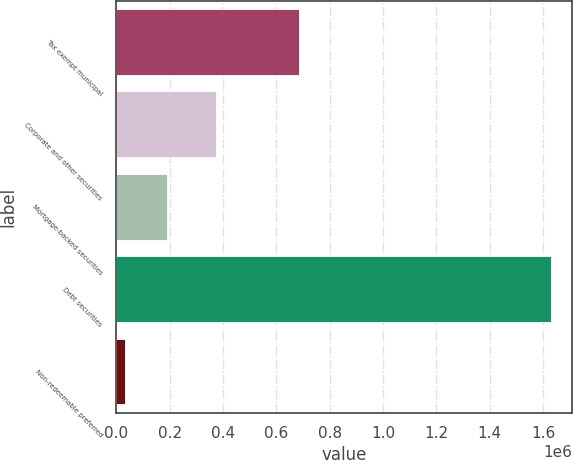Convert chart. <chart><loc_0><loc_0><loc_500><loc_500><bar_chart><fcel>Tax exempt municipal<fcel>Corporate and other securities<fcel>Mortgage-backed securities<fcel>Debt securities<fcel>Non-redeemable preferred<nl><fcel>686552<fcel>374568<fcel>190905<fcel>1.62851e+06<fcel>31171<nl></chart> 